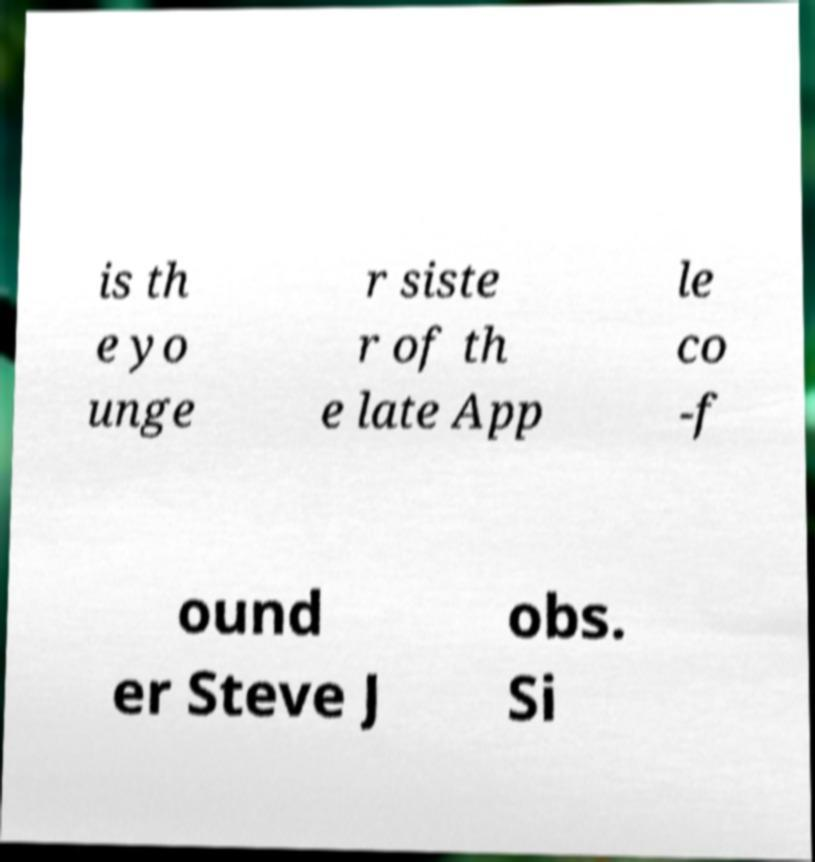Please read and relay the text visible in this image. What does it say? is th e yo unge r siste r of th e late App le co -f ound er Steve J obs. Si 